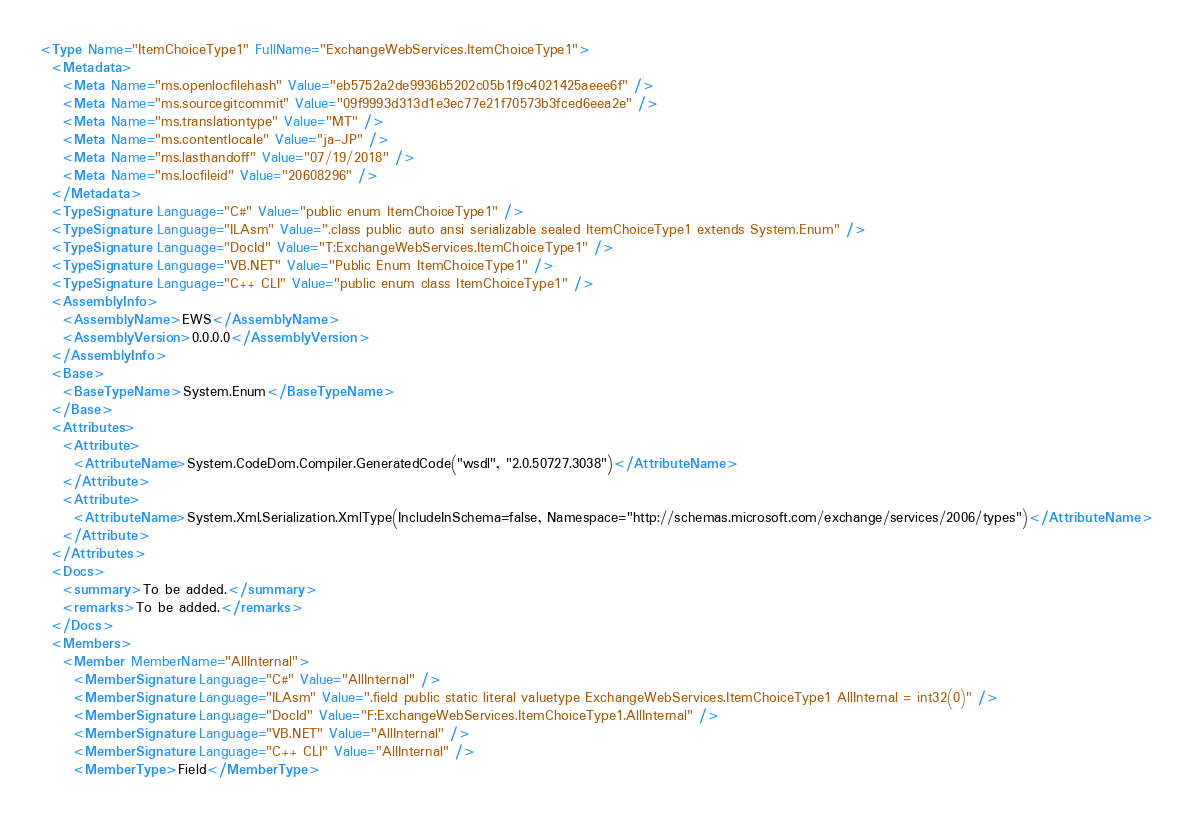Convert code to text. <code><loc_0><loc_0><loc_500><loc_500><_XML_><Type Name="ItemChoiceType1" FullName="ExchangeWebServices.ItemChoiceType1">
  <Metadata>
    <Meta Name="ms.openlocfilehash" Value="eb5752a2de9936b5202c05b1f9c4021425aeee6f" />
    <Meta Name="ms.sourcegitcommit" Value="09f9993d313d1e3ec77e21f70573b3fced6eea2e" />
    <Meta Name="ms.translationtype" Value="MT" />
    <Meta Name="ms.contentlocale" Value="ja-JP" />
    <Meta Name="ms.lasthandoff" Value="07/19/2018" />
    <Meta Name="ms.locfileid" Value="20608296" />
  </Metadata>
  <TypeSignature Language="C#" Value="public enum ItemChoiceType1" />
  <TypeSignature Language="ILAsm" Value=".class public auto ansi serializable sealed ItemChoiceType1 extends System.Enum" />
  <TypeSignature Language="DocId" Value="T:ExchangeWebServices.ItemChoiceType1" />
  <TypeSignature Language="VB.NET" Value="Public Enum ItemChoiceType1" />
  <TypeSignature Language="C++ CLI" Value="public enum class ItemChoiceType1" />
  <AssemblyInfo>
    <AssemblyName>EWS</AssemblyName>
    <AssemblyVersion>0.0.0.0</AssemblyVersion>
  </AssemblyInfo>
  <Base>
    <BaseTypeName>System.Enum</BaseTypeName>
  </Base>
  <Attributes>
    <Attribute>
      <AttributeName>System.CodeDom.Compiler.GeneratedCode("wsdl", "2.0.50727.3038")</AttributeName>
    </Attribute>
    <Attribute>
      <AttributeName>System.Xml.Serialization.XmlType(IncludeInSchema=false, Namespace="http://schemas.microsoft.com/exchange/services/2006/types")</AttributeName>
    </Attribute>
  </Attributes>
  <Docs>
    <summary>To be added.</summary>
    <remarks>To be added.</remarks>
  </Docs>
  <Members>
    <Member MemberName="AllInternal">
      <MemberSignature Language="C#" Value="AllInternal" />
      <MemberSignature Language="ILAsm" Value=".field public static literal valuetype ExchangeWebServices.ItemChoiceType1 AllInternal = int32(0)" />
      <MemberSignature Language="DocId" Value="F:ExchangeWebServices.ItemChoiceType1.AllInternal" />
      <MemberSignature Language="VB.NET" Value="AllInternal" />
      <MemberSignature Language="C++ CLI" Value="AllInternal" />
      <MemberType>Field</MemberType></code> 